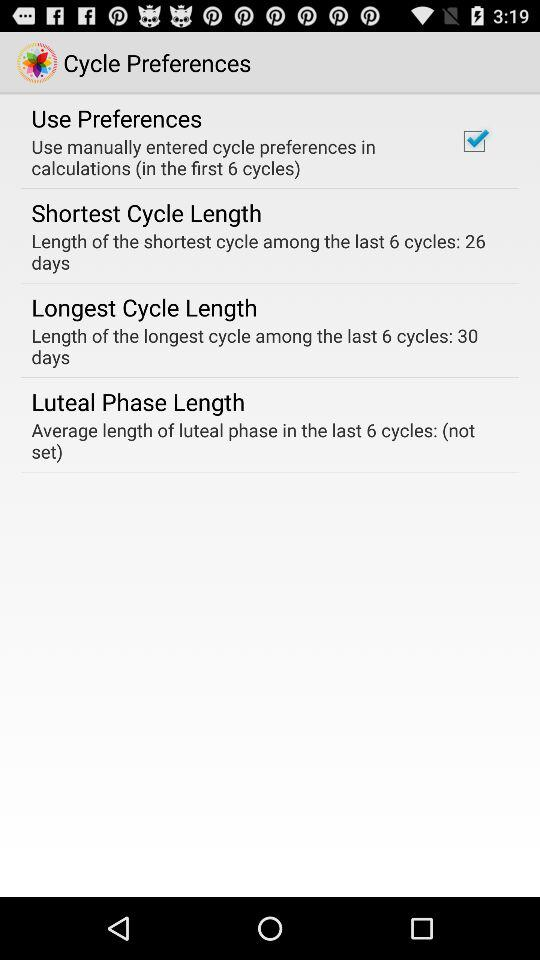What is the longest cycle length? The longest cycle length is 30 days. 